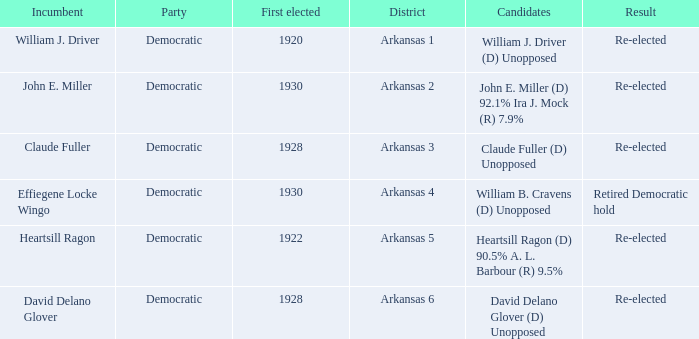In what district was John E. Miller the incumbent?  Arkansas 2. 